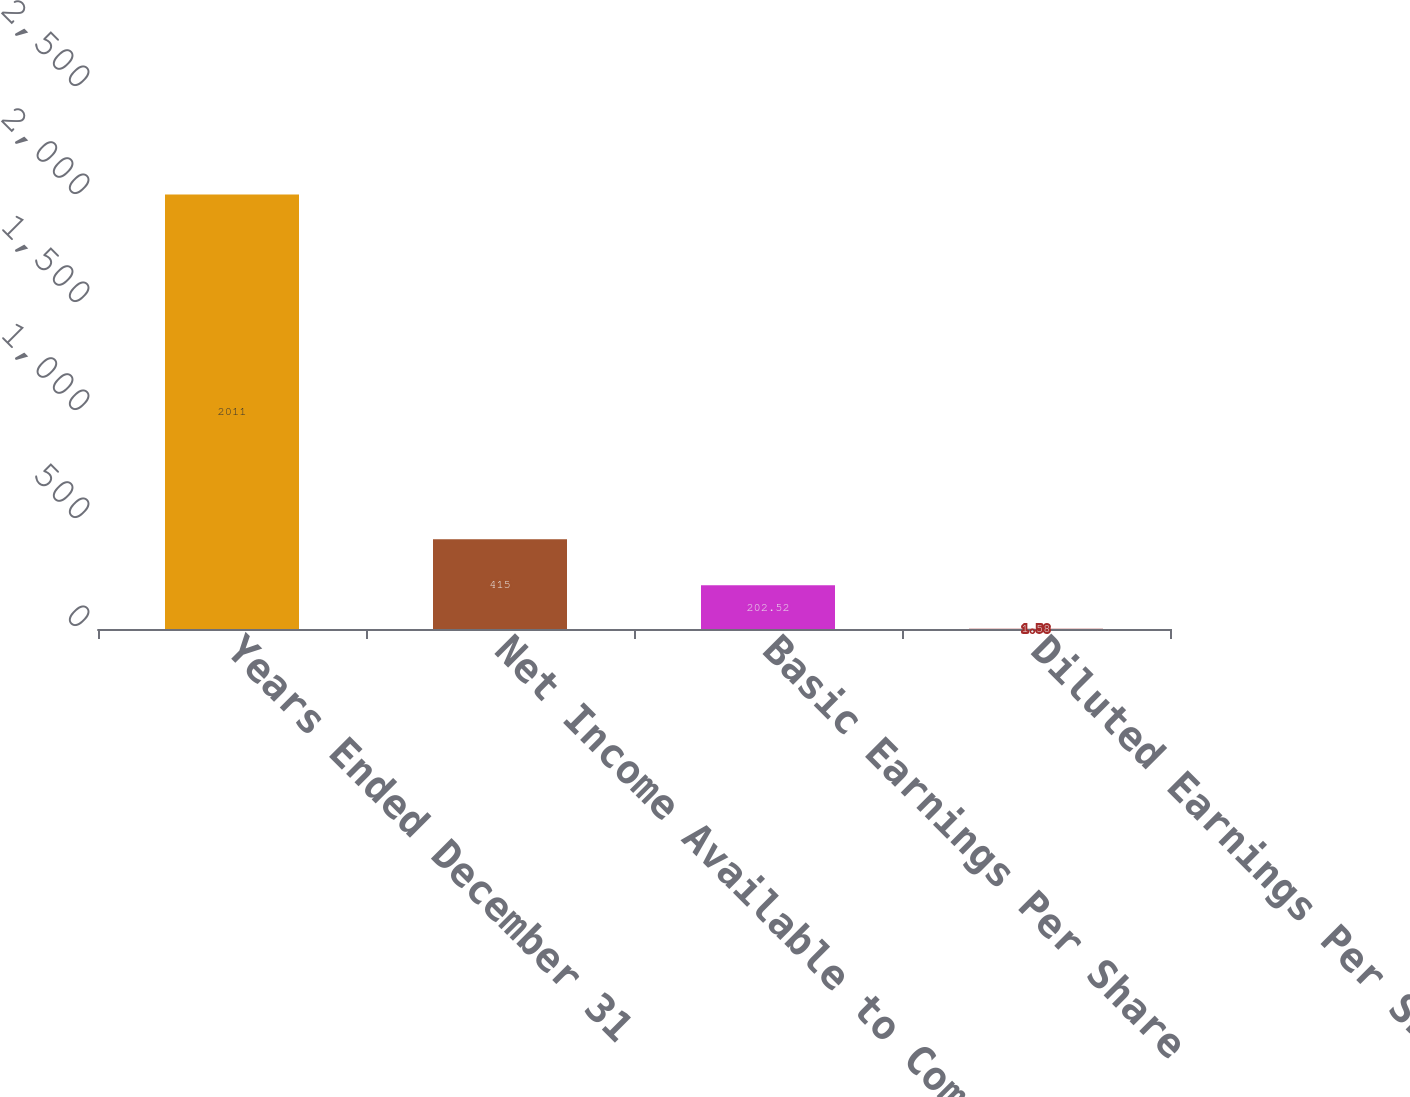Convert chart. <chart><loc_0><loc_0><loc_500><loc_500><bar_chart><fcel>Years Ended December 31<fcel>Net Income Available to Common<fcel>Basic Earnings Per Share<fcel>Diluted Earnings Per Share<nl><fcel>2011<fcel>415<fcel>202.52<fcel>1.58<nl></chart> 